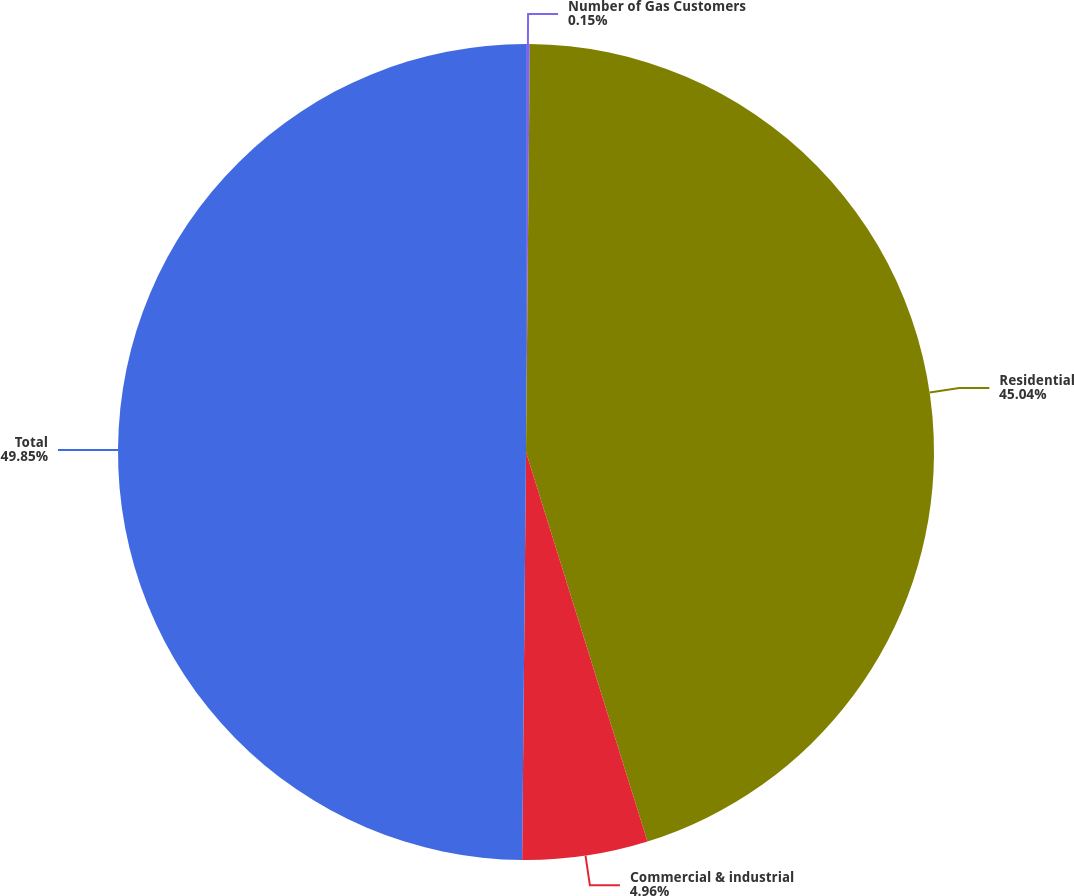Convert chart. <chart><loc_0><loc_0><loc_500><loc_500><pie_chart><fcel>Number of Gas Customers<fcel>Residential<fcel>Commercial & industrial<fcel>Total<nl><fcel>0.15%<fcel>45.04%<fcel>4.96%<fcel>49.85%<nl></chart> 